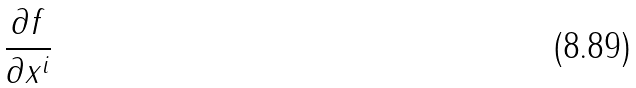<formula> <loc_0><loc_0><loc_500><loc_500>\frac { \partial f } { \partial x ^ { i } }</formula> 